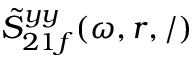Convert formula to latex. <formula><loc_0><loc_0><loc_500><loc_500>\tilde { S } _ { 2 1 f } ^ { y y } ( \omega , r , / )</formula> 